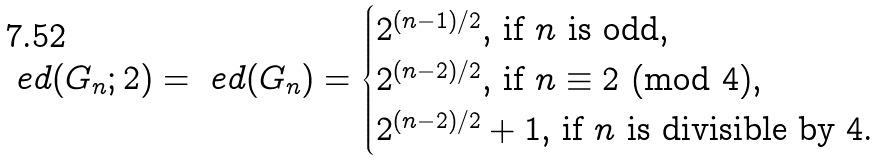<formula> <loc_0><loc_0><loc_500><loc_500>\ e d ( G _ { n } ; 2 ) = \ e d ( G _ { n } ) = \begin{cases} \text {$2^{(n-1)/2}$, if $n$ is odd,} \\ \text {$2^{(n-2)/2}$, if $n \equiv 2$ (mod $4$),} \\ \text {$2^{(n-2)/2} + 1$, if $n$ is divisible by $4$.} \end{cases}</formula> 